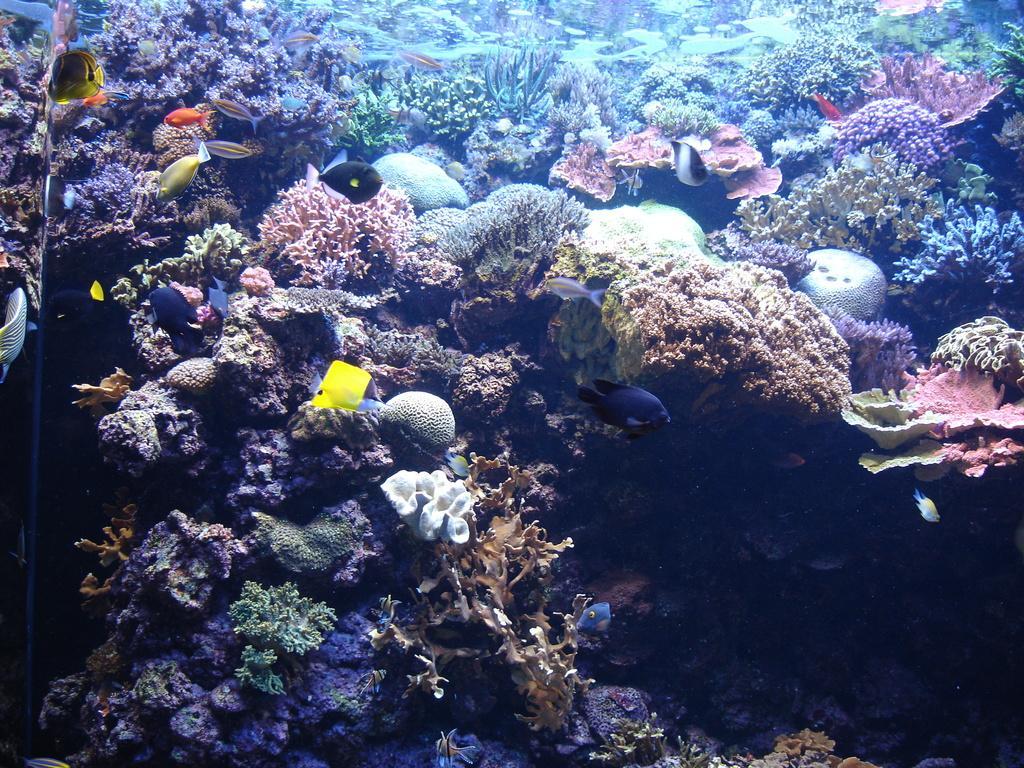Can you describe this image briefly? This image consists of coral leaves and fishes. It looks like it is clicked under the water. 